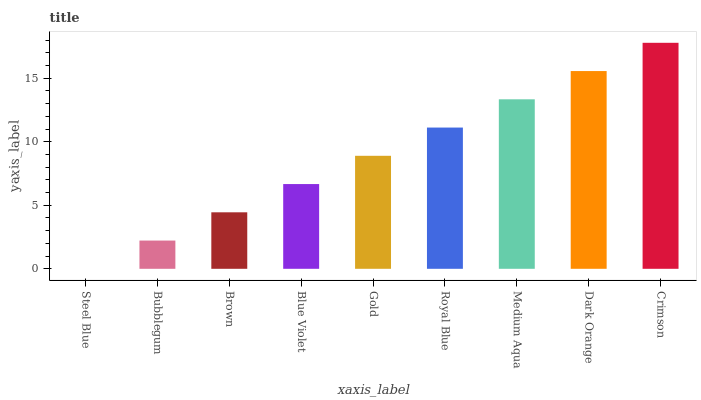Is Steel Blue the minimum?
Answer yes or no. Yes. Is Crimson the maximum?
Answer yes or no. Yes. Is Bubblegum the minimum?
Answer yes or no. No. Is Bubblegum the maximum?
Answer yes or no. No. Is Bubblegum greater than Steel Blue?
Answer yes or no. Yes. Is Steel Blue less than Bubblegum?
Answer yes or no. Yes. Is Steel Blue greater than Bubblegum?
Answer yes or no. No. Is Bubblegum less than Steel Blue?
Answer yes or no. No. Is Gold the high median?
Answer yes or no. Yes. Is Gold the low median?
Answer yes or no. Yes. Is Bubblegum the high median?
Answer yes or no. No. Is Brown the low median?
Answer yes or no. No. 